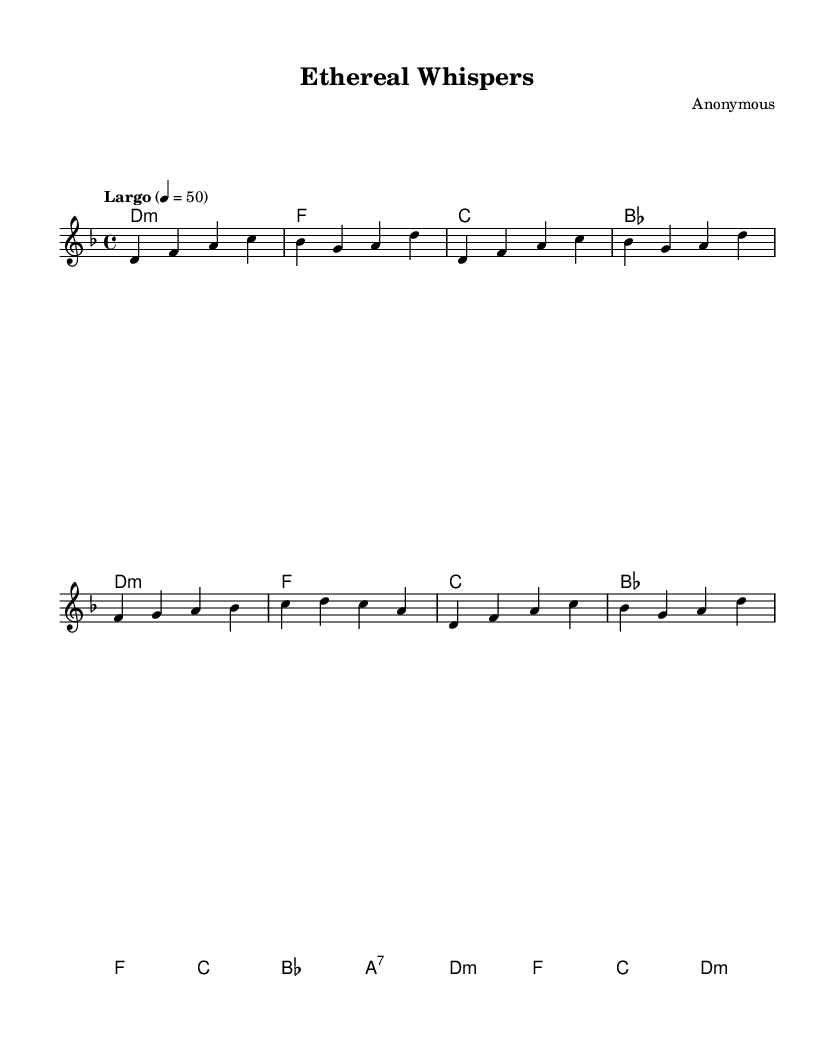What is the key signature of this music? The key signature is D minor, which includes one flat (B flat). You can identify the key signature by looking at the beginning of the music sheet where it is indicated, showing one flat.
Answer: D minor What is the time signature of this piece? The time signature is 4/4, which is indicated at the beginning of the music. It shows that there are four beats in each measure and the quarter note gets one beat.
Answer: 4/4 What is the tempo marking for this composition? The tempo marking indicates "Largo," which means to play slowly. It is indicated above the staff as a tempo instruction and typically corresponds to a slow pace.
Answer: Largo How many measures are there in the melody? The melody consists of 8 measures, which can be counted by looking at the vertical lines that separate the measures in the sheet music.
Answer: 8 What is the final chord in the harmonies? The final chord in the harmonies is D minor, as indicated in the last measure of the harmony section. It shows the chord that resolves at the conclusion of the piece.
Answer: D minor What type of music is "Ethereal Whispers"? "Ethereal Whispers" is a New Age instrumental composition, indicated by the atmospheric and mystical elements present in the melody and arrangement. It typically focuses on spiritual and contemplative themes.
Answer: New Age 